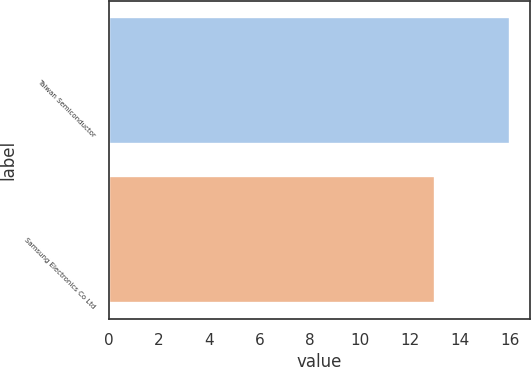Convert chart. <chart><loc_0><loc_0><loc_500><loc_500><bar_chart><fcel>Taiwan Semiconductor<fcel>Samsung Electronics Co Ltd<nl><fcel>16<fcel>13<nl></chart> 